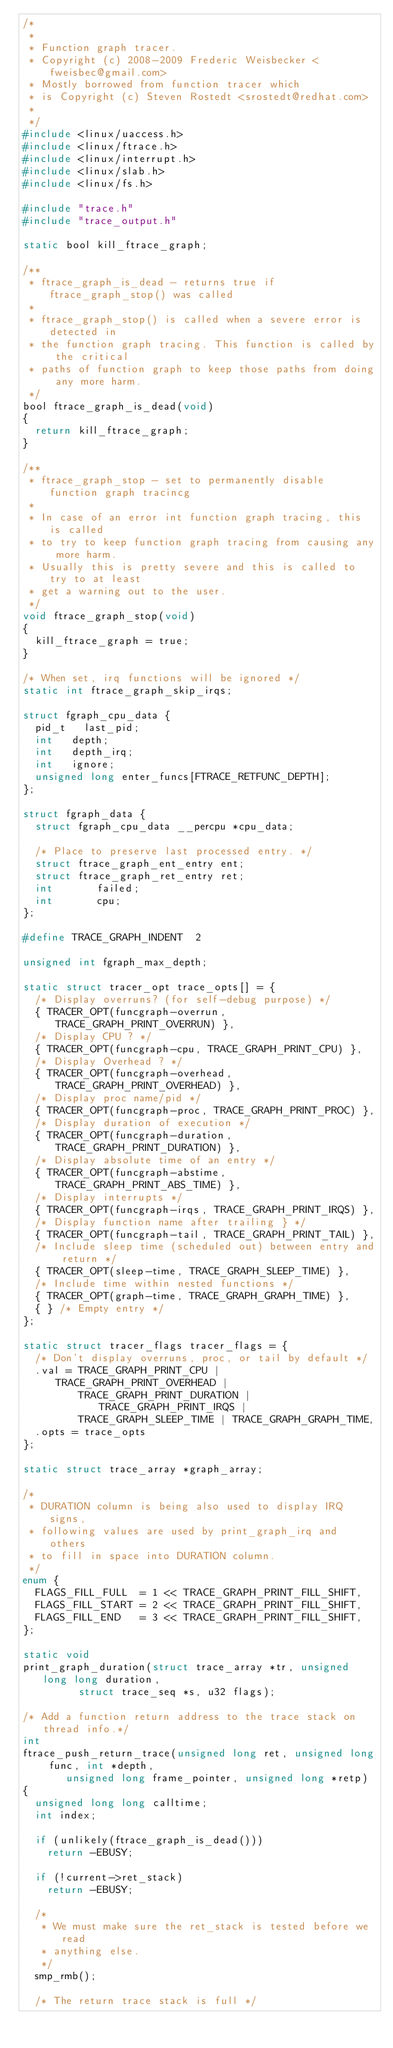<code> <loc_0><loc_0><loc_500><loc_500><_C_>/*
 *
 * Function graph tracer.
 * Copyright (c) 2008-2009 Frederic Weisbecker <fweisbec@gmail.com>
 * Mostly borrowed from function tracer which
 * is Copyright (c) Steven Rostedt <srostedt@redhat.com>
 *
 */
#include <linux/uaccess.h>
#include <linux/ftrace.h>
#include <linux/interrupt.h>
#include <linux/slab.h>
#include <linux/fs.h>

#include "trace.h"
#include "trace_output.h"

static bool kill_ftrace_graph;

/**
 * ftrace_graph_is_dead - returns true if ftrace_graph_stop() was called
 *
 * ftrace_graph_stop() is called when a severe error is detected in
 * the function graph tracing. This function is called by the critical
 * paths of function graph to keep those paths from doing any more harm.
 */
bool ftrace_graph_is_dead(void)
{
	return kill_ftrace_graph;
}

/**
 * ftrace_graph_stop - set to permanently disable function graph tracincg
 *
 * In case of an error int function graph tracing, this is called
 * to try to keep function graph tracing from causing any more harm.
 * Usually this is pretty severe and this is called to try to at least
 * get a warning out to the user.
 */
void ftrace_graph_stop(void)
{
	kill_ftrace_graph = true;
}

/* When set, irq functions will be ignored */
static int ftrace_graph_skip_irqs;

struct fgraph_cpu_data {
	pid_t		last_pid;
	int		depth;
	int		depth_irq;
	int		ignore;
	unsigned long	enter_funcs[FTRACE_RETFUNC_DEPTH];
};

struct fgraph_data {
	struct fgraph_cpu_data __percpu *cpu_data;

	/* Place to preserve last processed entry. */
	struct ftrace_graph_ent_entry	ent;
	struct ftrace_graph_ret_entry	ret;
	int				failed;
	int				cpu;
};

#define TRACE_GRAPH_INDENT	2

unsigned int fgraph_max_depth;

static struct tracer_opt trace_opts[] = {
	/* Display overruns? (for self-debug purpose) */
	{ TRACER_OPT(funcgraph-overrun, TRACE_GRAPH_PRINT_OVERRUN) },
	/* Display CPU ? */
	{ TRACER_OPT(funcgraph-cpu, TRACE_GRAPH_PRINT_CPU) },
	/* Display Overhead ? */
	{ TRACER_OPT(funcgraph-overhead, TRACE_GRAPH_PRINT_OVERHEAD) },
	/* Display proc name/pid */
	{ TRACER_OPT(funcgraph-proc, TRACE_GRAPH_PRINT_PROC) },
	/* Display duration of execution */
	{ TRACER_OPT(funcgraph-duration, TRACE_GRAPH_PRINT_DURATION) },
	/* Display absolute time of an entry */
	{ TRACER_OPT(funcgraph-abstime, TRACE_GRAPH_PRINT_ABS_TIME) },
	/* Display interrupts */
	{ TRACER_OPT(funcgraph-irqs, TRACE_GRAPH_PRINT_IRQS) },
	/* Display function name after trailing } */
	{ TRACER_OPT(funcgraph-tail, TRACE_GRAPH_PRINT_TAIL) },
	/* Include sleep time (scheduled out) between entry and return */
	{ TRACER_OPT(sleep-time, TRACE_GRAPH_SLEEP_TIME) },
	/* Include time within nested functions */
	{ TRACER_OPT(graph-time, TRACE_GRAPH_GRAPH_TIME) },
	{ } /* Empty entry */
};

static struct tracer_flags tracer_flags = {
	/* Don't display overruns, proc, or tail by default */
	.val = TRACE_GRAPH_PRINT_CPU | TRACE_GRAPH_PRINT_OVERHEAD |
	       TRACE_GRAPH_PRINT_DURATION | TRACE_GRAPH_PRINT_IRQS |
	       TRACE_GRAPH_SLEEP_TIME | TRACE_GRAPH_GRAPH_TIME,
	.opts = trace_opts
};

static struct trace_array *graph_array;

/*
 * DURATION column is being also used to display IRQ signs,
 * following values are used by print_graph_irq and others
 * to fill in space into DURATION column.
 */
enum {
	FLAGS_FILL_FULL  = 1 << TRACE_GRAPH_PRINT_FILL_SHIFT,
	FLAGS_FILL_START = 2 << TRACE_GRAPH_PRINT_FILL_SHIFT,
	FLAGS_FILL_END   = 3 << TRACE_GRAPH_PRINT_FILL_SHIFT,
};

static void
print_graph_duration(struct trace_array *tr, unsigned long long duration,
		     struct trace_seq *s, u32 flags);

/* Add a function return address to the trace stack on thread info.*/
int
ftrace_push_return_trace(unsigned long ret, unsigned long func, int *depth,
			 unsigned long frame_pointer, unsigned long *retp)
{
	unsigned long long calltime;
	int index;

	if (unlikely(ftrace_graph_is_dead()))
		return -EBUSY;

	if (!current->ret_stack)
		return -EBUSY;

	/*
	 * We must make sure the ret_stack is tested before we read
	 * anything else.
	 */
	smp_rmb();

	/* The return trace stack is full */</code> 